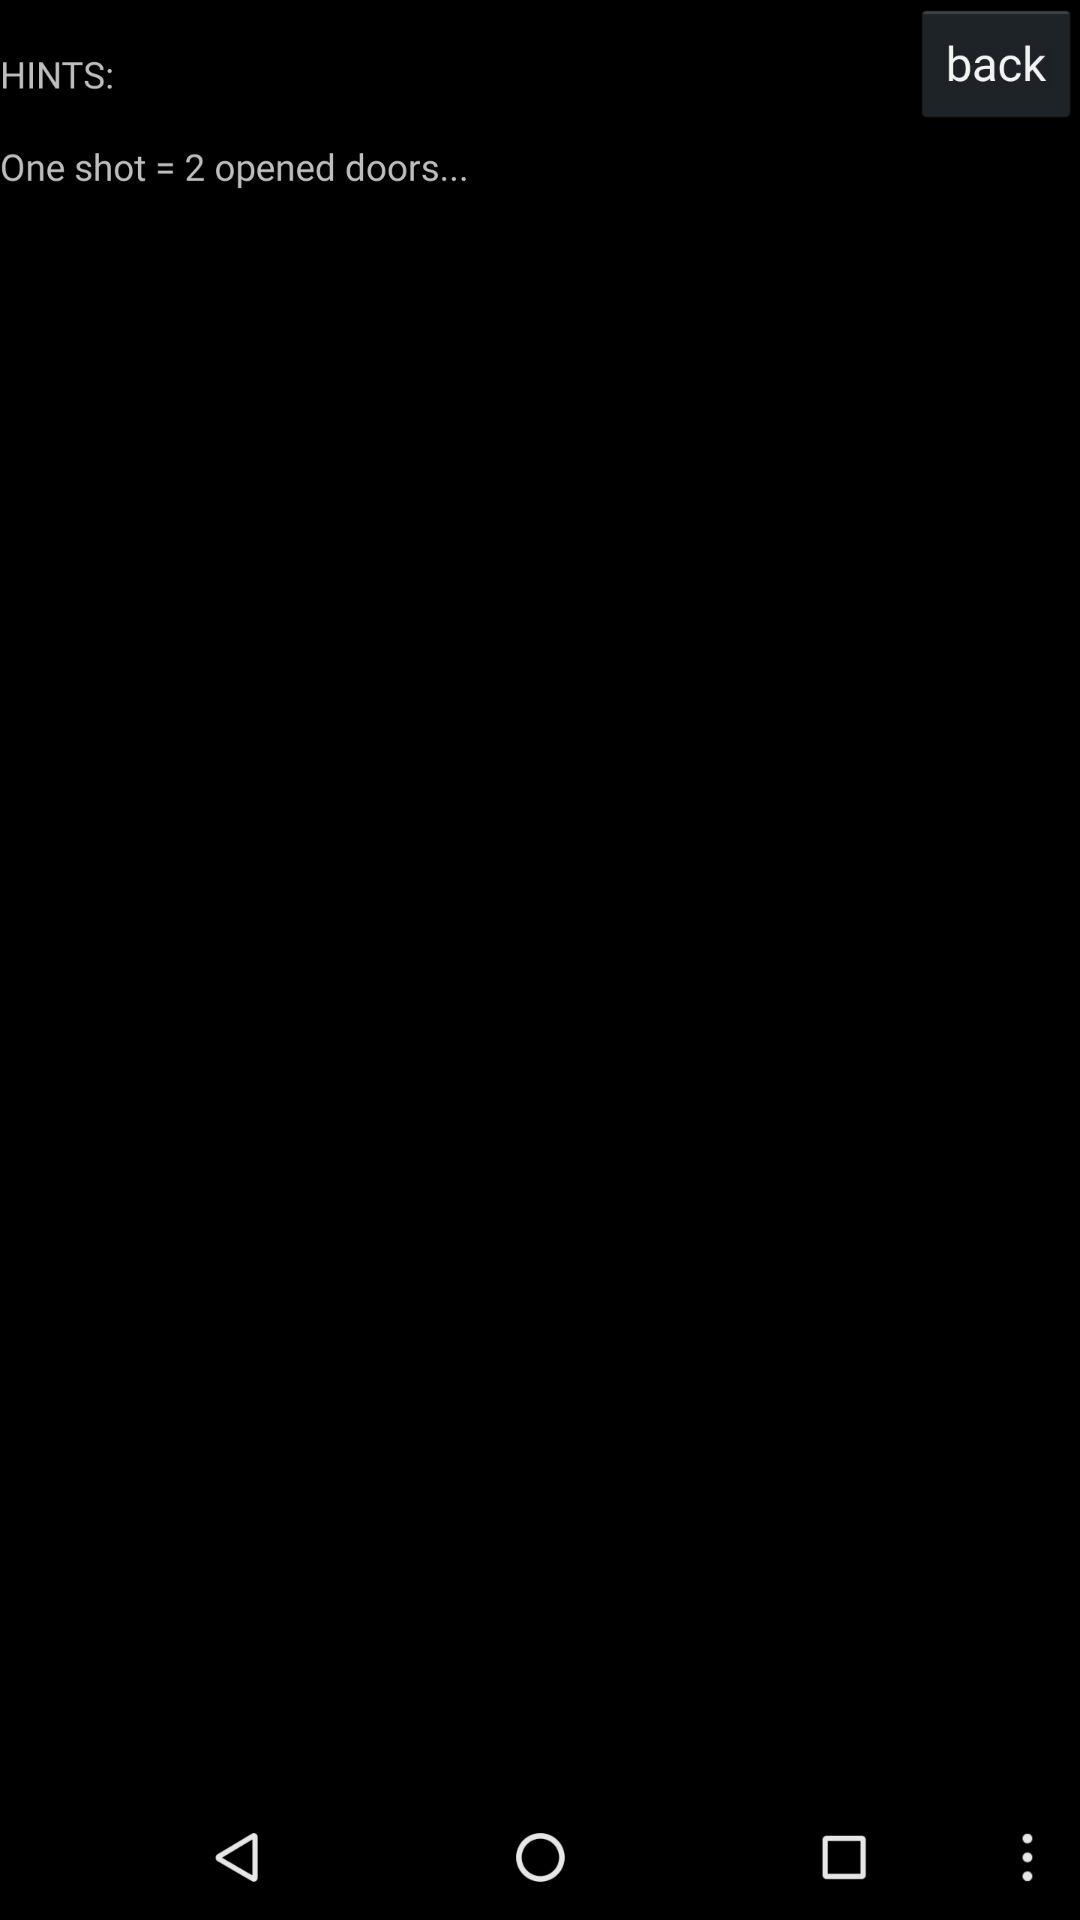How many shots are there? There is "one" shot. 